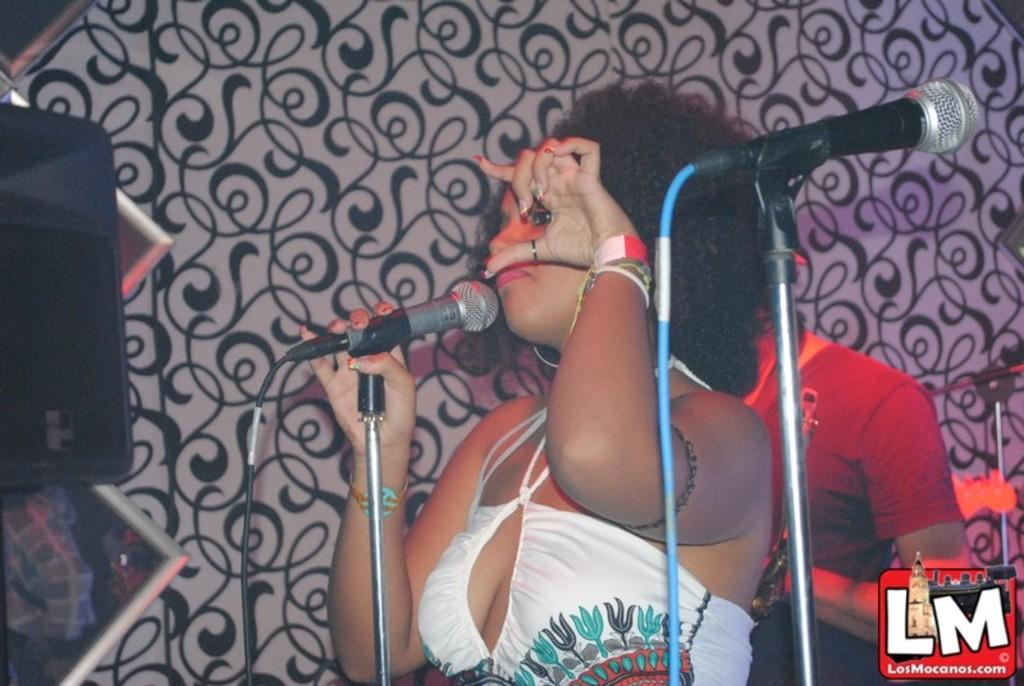Who is the main subject in the image? There is a woman in the image. What is the woman holding in the image? The woman is holding a microphone. Can you describe the person visible behind the woman? There is a person visible behind the woman, but no specific details are provided. What other object related to the microphone can be seen in the image? There is a microphone stand in the image. What type of tooth is visible in the image? There is no tooth visible in the image. How does the lock on the microphone stand work in the image? There is no lock on the microphone stand in the image. 